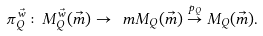Convert formula to latex. <formula><loc_0><loc_0><loc_500><loc_500>\pi _ { Q } ^ { \vec { w } } \colon M _ { Q } ^ { \vec { w } } ( \vec { m } ) \to \ m M _ { Q } ( \vec { m } ) \stackrel { p _ { Q } } { \to } M _ { Q } ( \vec { m } ) .</formula> 